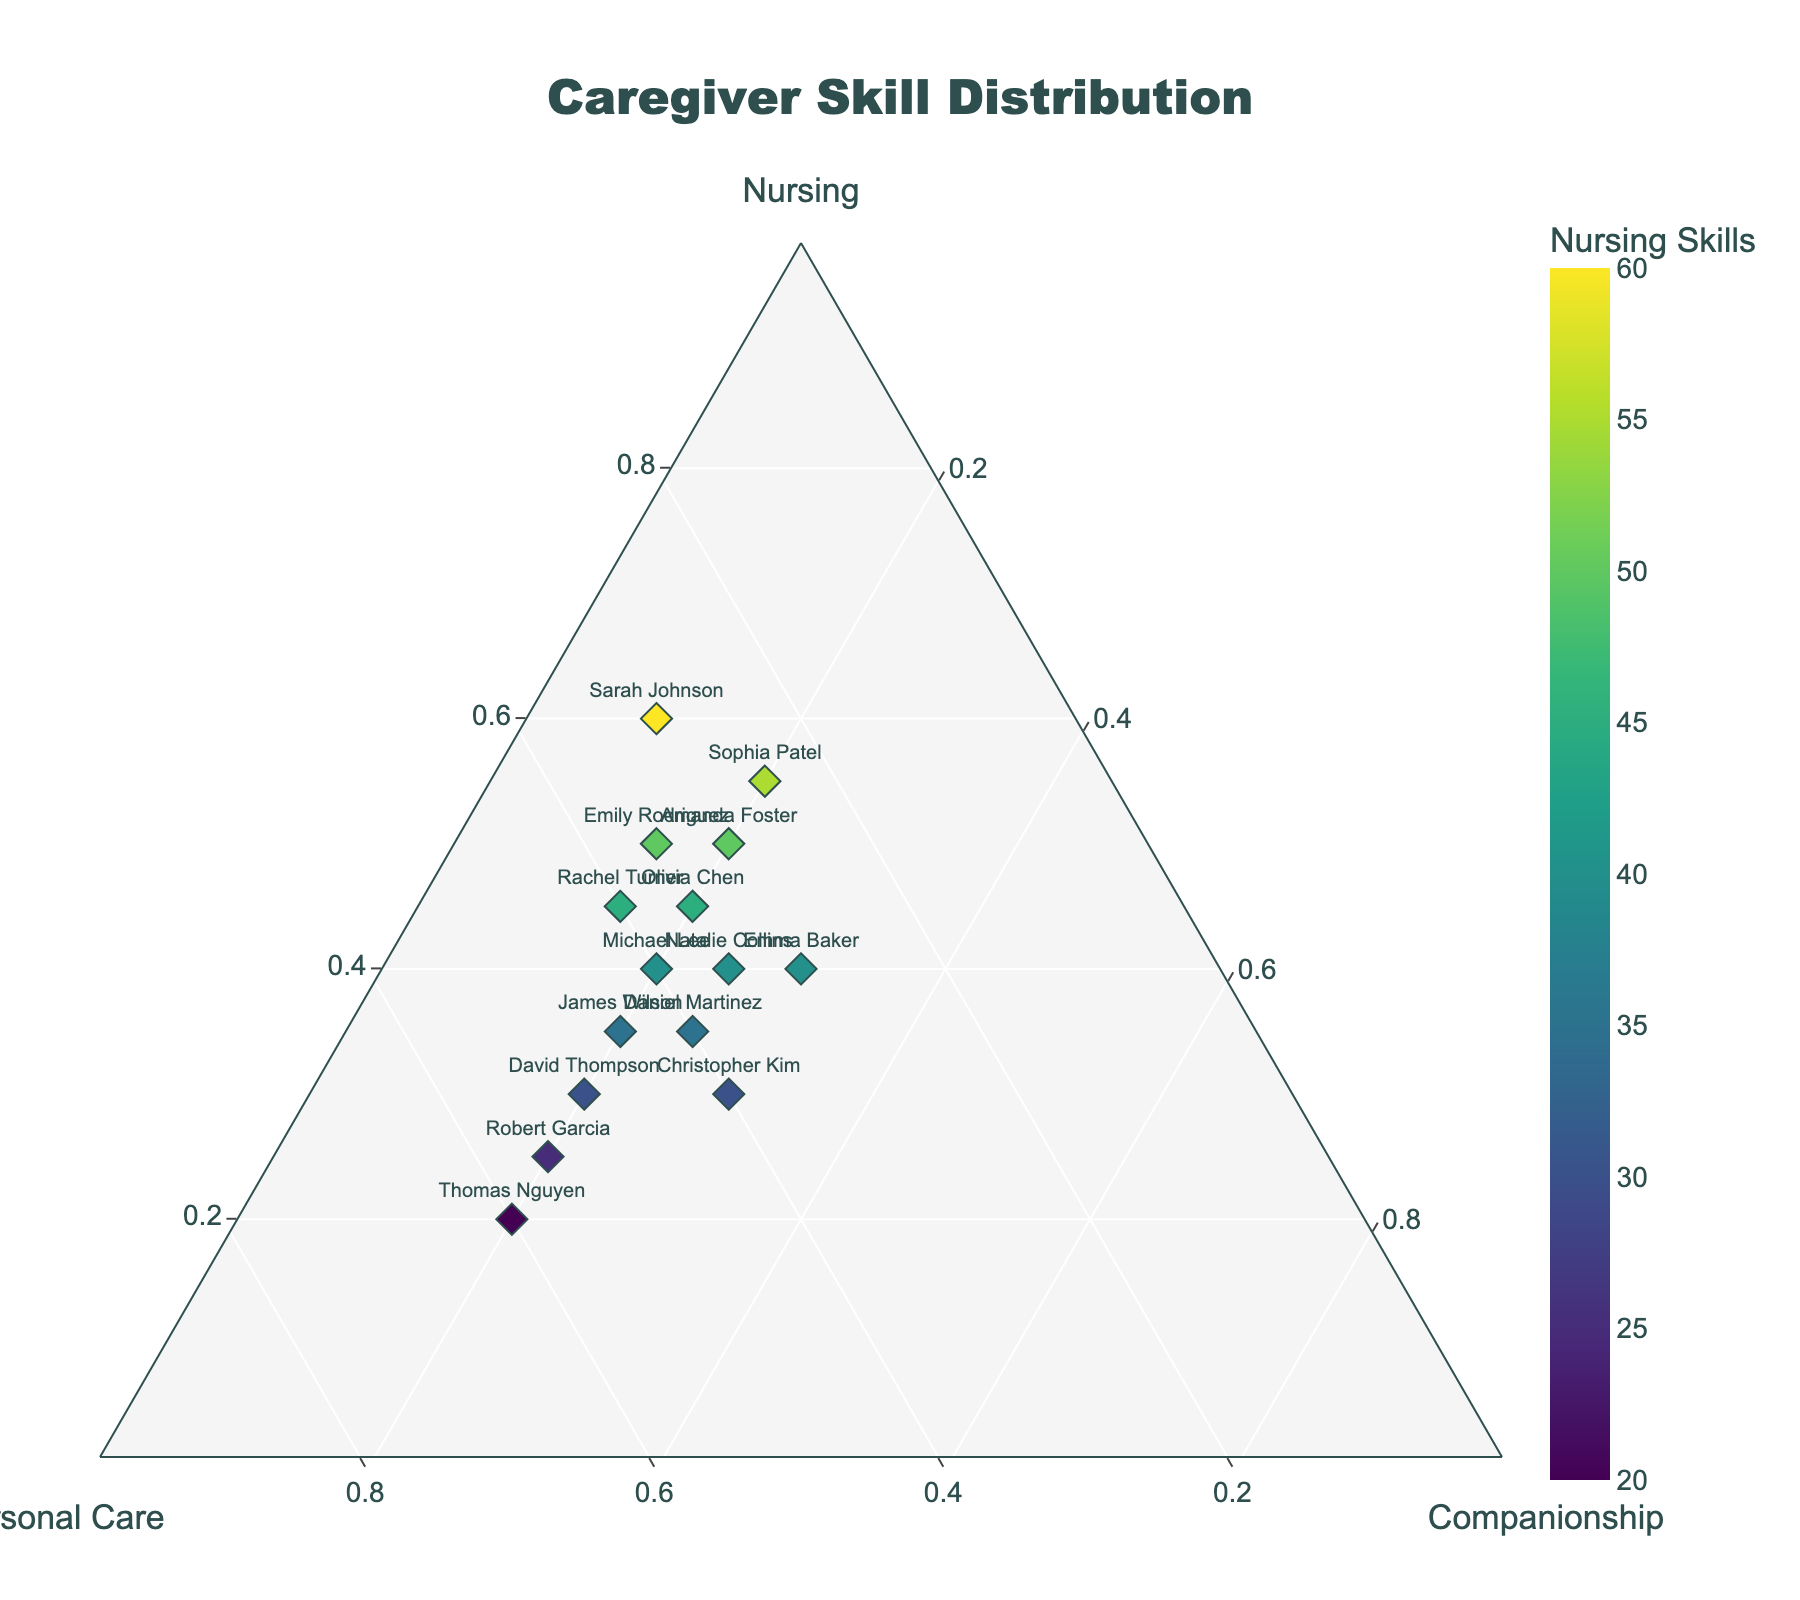what is the title of the plot? The title of the plot is located at the top center of the figure. It provides a summary of what the plot is about.
Answer: Caregiver Skill Distribution How many caregivers show in the plot? There are unique markers on the plot, and each marker represents a caregiver. Count the number of markers to get the total number of caregivers.
Answer: 15 Which caregiver has the highest nursing skill? Identify the caregiver(s) whose marker is plotted furthest along the Nursing (a-axis) axis. The highest value for nursing skill is 60.
Answer: Sarah Johnson Who has equal distribution between personal care and companionship skills? Look for caregivers with identical values in the Personal Care and Companionship axes, i.e., the same distance from the origin along both axes.
Answer: Emma Baker Is there any caregiver with 50% or more in personal care? Check all caregivers whose markers fall beyond the 50% mark on the Personal Care axis. Only one caregiver has 50% or more.
Answer: David Thompson What is the range of companionship skills among the caregivers? The range can be found by identifying the minimum and maximum values on the Companionship axis, then subtracting the minimum from the maximum. The minimum is 10 and the maximum is 30.
Answer: 20 Who are the caregivers with the highest and lowest personal care skills? Compare all caregivers' positions along the Personal Care axis to determine the highest and lowest values. Amanda Foster has the highest value (60), and Sarah Johnson has the lowest value (30).
Answer: Amanda Foster, Sarah Johnson Is there a correlation between nursing and companionship? Visually inspect the plot for any pattern or trend line that shows a relationship between the Nursing and Companionship skills. If no clear trend is observed, it suggests a lack of correlation.
Answer: No clear correlation 